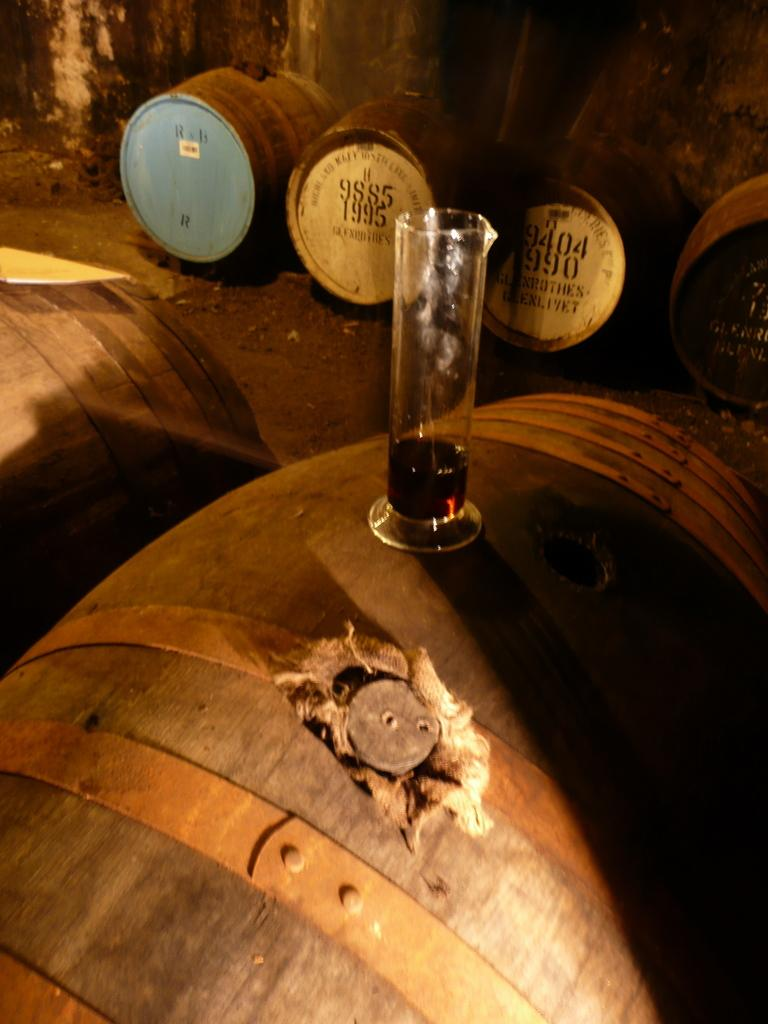What is the main object in the center of the image? There is a test tube in the center of the image. What is the test tube placed on? The test tube is on a barrel. What can be seen in the background of the image? There are barrels and a wall visible in the background of the image. Can you see a baby pushing a key in the image? No, there is no baby or key present in the image. 